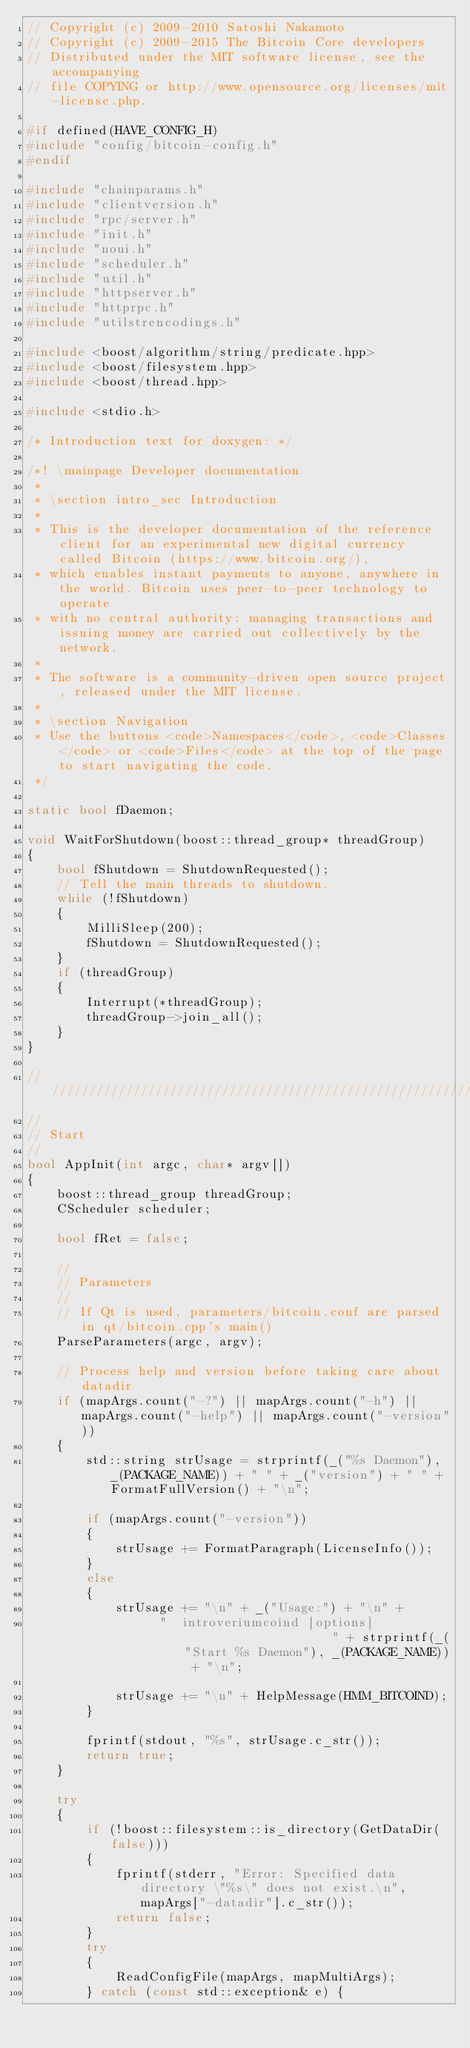<code> <loc_0><loc_0><loc_500><loc_500><_C++_>// Copyright (c) 2009-2010 Satoshi Nakamoto
// Copyright (c) 2009-2015 The Bitcoin Core developers
// Distributed under the MIT software license, see the accompanying
// file COPYING or http://www.opensource.org/licenses/mit-license.php.

#if defined(HAVE_CONFIG_H)
#include "config/bitcoin-config.h"
#endif

#include "chainparams.h"
#include "clientversion.h"
#include "rpc/server.h"
#include "init.h"
#include "noui.h"
#include "scheduler.h"
#include "util.h"
#include "httpserver.h"
#include "httprpc.h"
#include "utilstrencodings.h"

#include <boost/algorithm/string/predicate.hpp>
#include <boost/filesystem.hpp>
#include <boost/thread.hpp>

#include <stdio.h>

/* Introduction text for doxygen: */

/*! \mainpage Developer documentation
 *
 * \section intro_sec Introduction
 *
 * This is the developer documentation of the reference client for an experimental new digital currency called Bitcoin (https://www.bitcoin.org/),
 * which enables instant payments to anyone, anywhere in the world. Bitcoin uses peer-to-peer technology to operate
 * with no central authority: managing transactions and issuing money are carried out collectively by the network.
 *
 * The software is a community-driven open source project, released under the MIT license.
 *
 * \section Navigation
 * Use the buttons <code>Namespaces</code>, <code>Classes</code> or <code>Files</code> at the top of the page to start navigating the code.
 */

static bool fDaemon;

void WaitForShutdown(boost::thread_group* threadGroup)
{
    bool fShutdown = ShutdownRequested();
    // Tell the main threads to shutdown.
    while (!fShutdown)
    {
        MilliSleep(200);
        fShutdown = ShutdownRequested();
    }
    if (threadGroup)
    {
        Interrupt(*threadGroup);
        threadGroup->join_all();
    }
}

//////////////////////////////////////////////////////////////////////////////
//
// Start
//
bool AppInit(int argc, char* argv[])
{
    boost::thread_group threadGroup;
    CScheduler scheduler;

    bool fRet = false;

    //
    // Parameters
    //
    // If Qt is used, parameters/bitcoin.conf are parsed in qt/bitcoin.cpp's main()
    ParseParameters(argc, argv);

    // Process help and version before taking care about datadir
    if (mapArgs.count("-?") || mapArgs.count("-h") ||  mapArgs.count("-help") || mapArgs.count("-version"))
    {
        std::string strUsage = strprintf(_("%s Daemon"), _(PACKAGE_NAME)) + " " + _("version") + " " + FormatFullVersion() + "\n";

        if (mapArgs.count("-version"))
        {
            strUsage += FormatParagraph(LicenseInfo());
        }
        else
        {
            strUsage += "\n" + _("Usage:") + "\n" +
                  "  introveriumcoind [options]                     " + strprintf(_("Start %s Daemon"), _(PACKAGE_NAME)) + "\n";

            strUsage += "\n" + HelpMessage(HMM_BITCOIND);
        }

        fprintf(stdout, "%s", strUsage.c_str());
        return true;
    }

    try
    {
        if (!boost::filesystem::is_directory(GetDataDir(false)))
        {
            fprintf(stderr, "Error: Specified data directory \"%s\" does not exist.\n", mapArgs["-datadir"].c_str());
            return false;
        }
        try
        {
            ReadConfigFile(mapArgs, mapMultiArgs);
        } catch (const std::exception& e) {</code> 